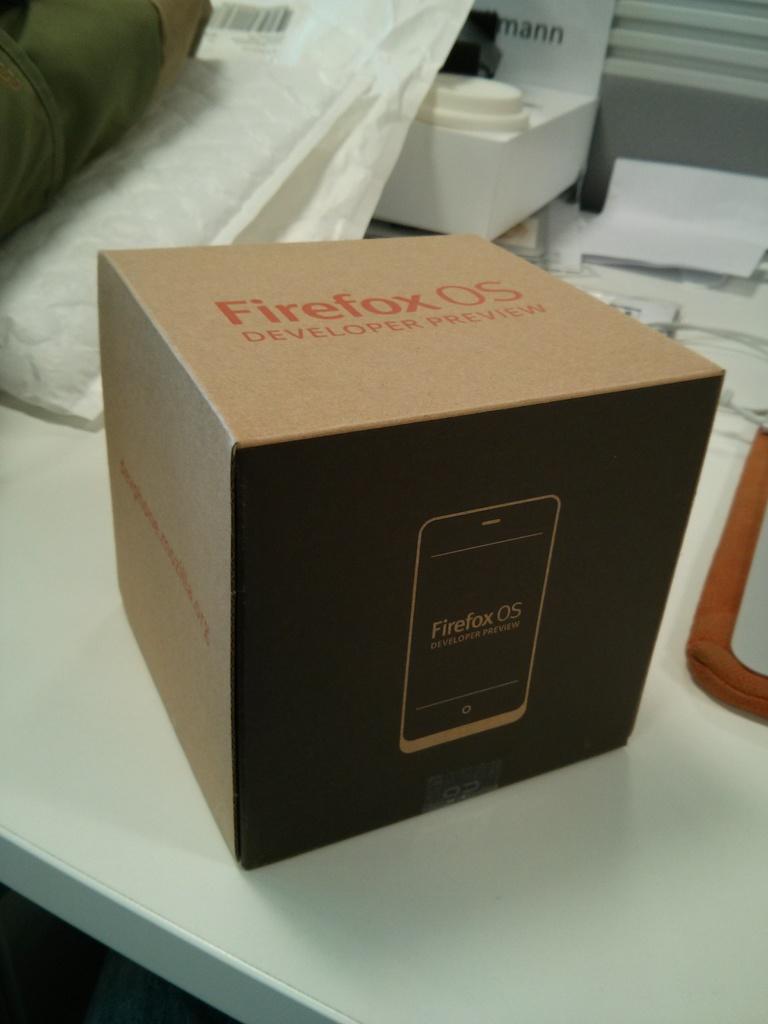Is this product only a developer preview?
Your answer should be compact. Yes. What os is mentioned on the box?
Offer a very short reply. Firefox. 